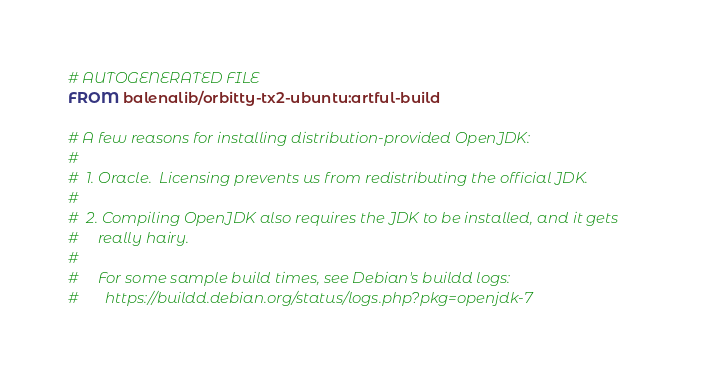Convert code to text. <code><loc_0><loc_0><loc_500><loc_500><_Dockerfile_># AUTOGENERATED FILE
FROM balenalib/orbitty-tx2-ubuntu:artful-build

# A few reasons for installing distribution-provided OpenJDK:
#
#  1. Oracle.  Licensing prevents us from redistributing the official JDK.
#
#  2. Compiling OpenJDK also requires the JDK to be installed, and it gets
#     really hairy.
#
#     For some sample build times, see Debian's buildd logs:
#       https://buildd.debian.org/status/logs.php?pkg=openjdk-7
</code> 